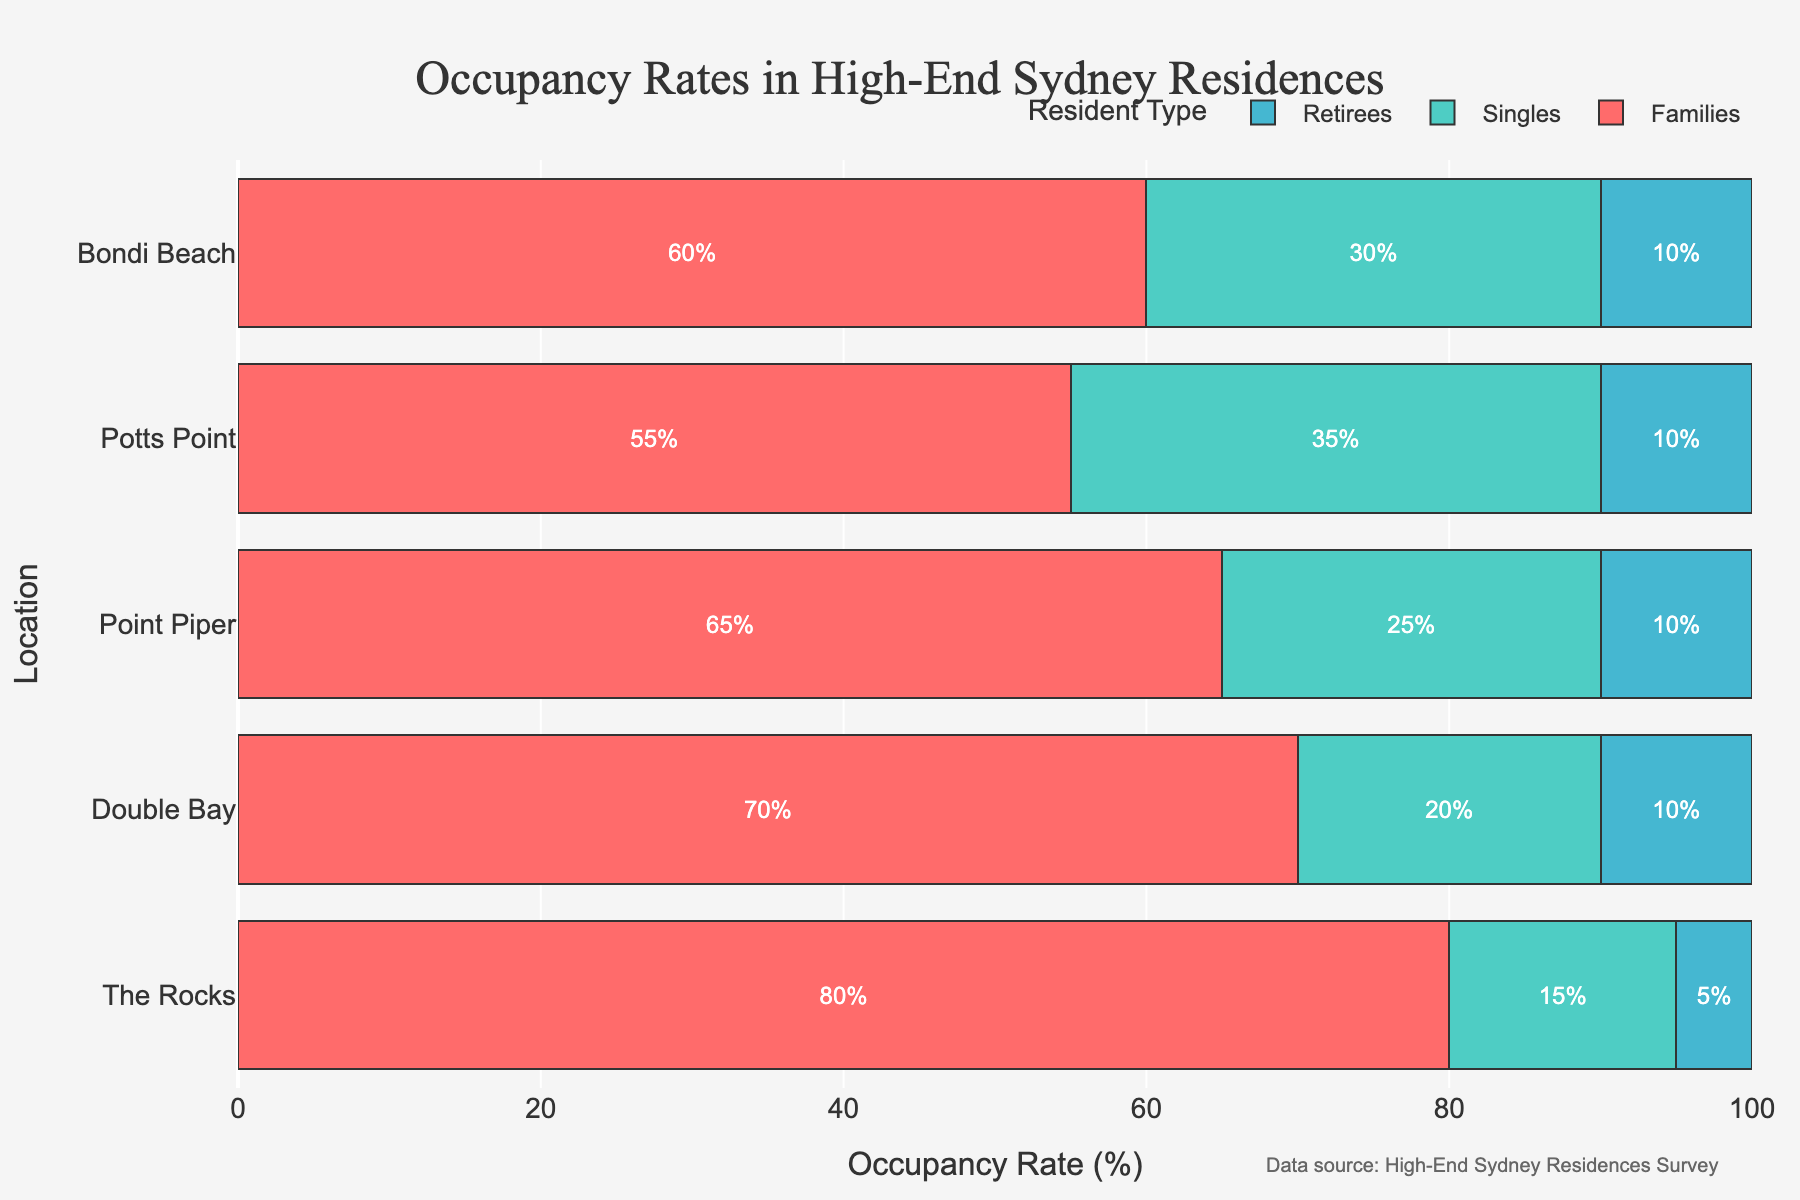Which location has the highest occupancy rate for retirees? Look at the retiree sections (10% gray) in each bar. Both Double Bay, Point Piper, Potts Point, and Bondi Beach have the same value (10%).
Answer: Double Bay, Point Piper, Potts Point, Bondi Beach Which resident type has the highest average occupancy rate across all locations? Calculate the average for each resident type: Families: (80 + 70 + 65 + 55 + 60) / 5 = 66, Singles: (15 + 20 + 25 + 35 + 30) / 5 = 25, Retirees: (5 + 10 + 10 + 10 + 10) / 5 = 9. Families have the highest average.
Answer: Families Which location has the highest combined occupancy rate for Singles and Retirees? For each location, sum the percentages of Singles and Retirees: The Rocks: 15 + 5 = 20, Double Bay: 20 + 10 = 30, Point Piper: 25 + 10 = 35, Potts Point: 35 + 10 = 45, Bondi Beach: 30 + 10 = 40. Potts Point has the highest combined rate.
Answer: Potts Point How does the occupancy rate for Singles in Potts Point compare to Singles in Point Piper? Look at the length of the green bar for Singles in Potts Point and Point Piper. Potts Point has 35% and Point Piper has 25%. Potts Point has a higher rate.
Answer: Potts Point is higher What is the total occupancy rate for families across all locations? Add the percentages for families in each location: 80 + 70 + 65 + 55 + 60 = 330.
Answer: 330% In which location is the proportion of Families the smallest? Compare the length of the red bars for each location. Potts Point has the smallest length at 55%.
Answer: Potts Point What is the difference in occupancy rates between Families in The Rocks and Singles in Bondi Beach? Subtract the occupancy rate of Singles in Bondi Beach (30%) from Families in The Rocks (80%): 80 - 30 = 50.
Answer: 50% What is the occupancy rate for singles in Double Bay, and how does it compare to Retirees in the same location? The occupancy rate for Singles in Double Bay is 20%, and for Retirees, it is 10%. Singles have a higher rate.
Answer: Singles are higher Which resident type has the lowest occupancy rate in The Rocks? The bar for Retirees is the smallest, with 5%.
Answer: Retirees 